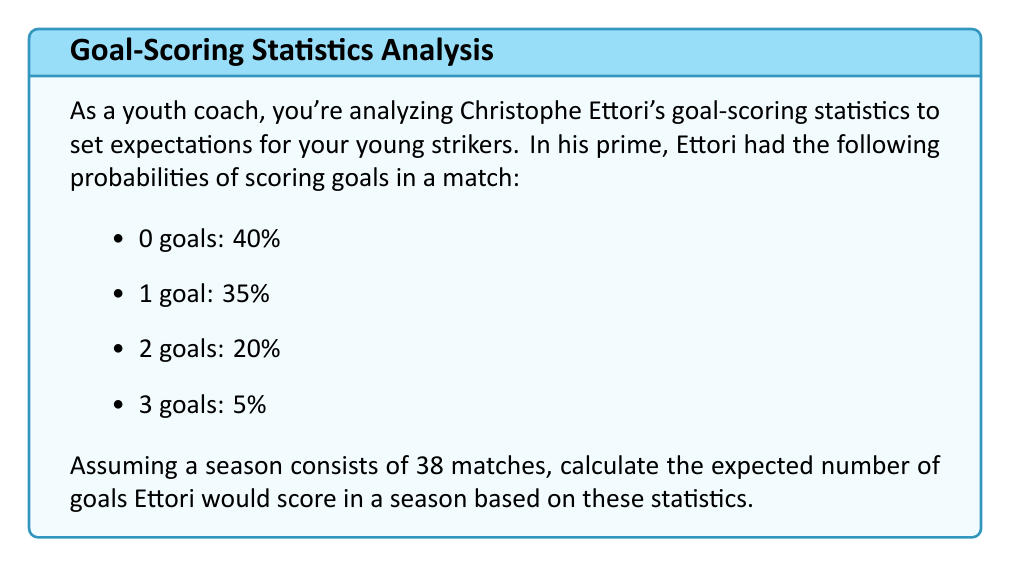Help me with this question. To calculate the expected number of goals in a season, we need to follow these steps:

1. Calculate the expected value of goals per match:
   Let $X$ be the random variable representing the number of goals scored in a match.
   
   $E(X) = 0 \cdot P(X=0) + 1 \cdot P(X=1) + 2 \cdot P(X=2) + 3 \cdot P(X=3)$
   
   $E(X) = 0 \cdot 0.40 + 1 \cdot 0.35 + 2 \cdot 0.20 + 3 \cdot 0.05$
   
   $E(X) = 0 + 0.35 + 0.40 + 0.15 = 0.90$ goals per match

2. Multiply the expected value per match by the number of matches in a season:
   
   Expected goals in a season $= E(X) \cdot \text{number of matches}$
   
   $= 0.90 \cdot 38 = 34.2$ goals

Therefore, based on Ettori's statistics, the expected number of goals he would score in a 38-match season is 34.2 goals.
Answer: 34.2 goals 